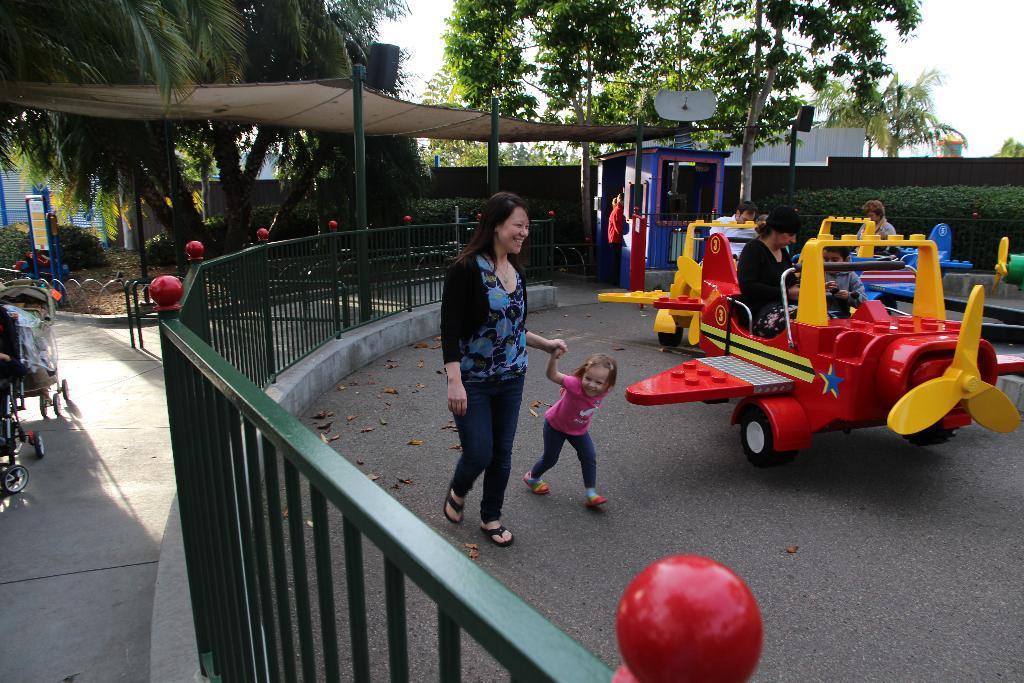Could you give a brief overview of what you see in this image? In this image we can see some people sitting in the toy vehicles which are placed on the ground. We can also see some people standing, a fence, poles, a tent, booth, plants, building, a dish, a group of trees and the sky. On the left side we can see a board and some trolleys on the surface. 